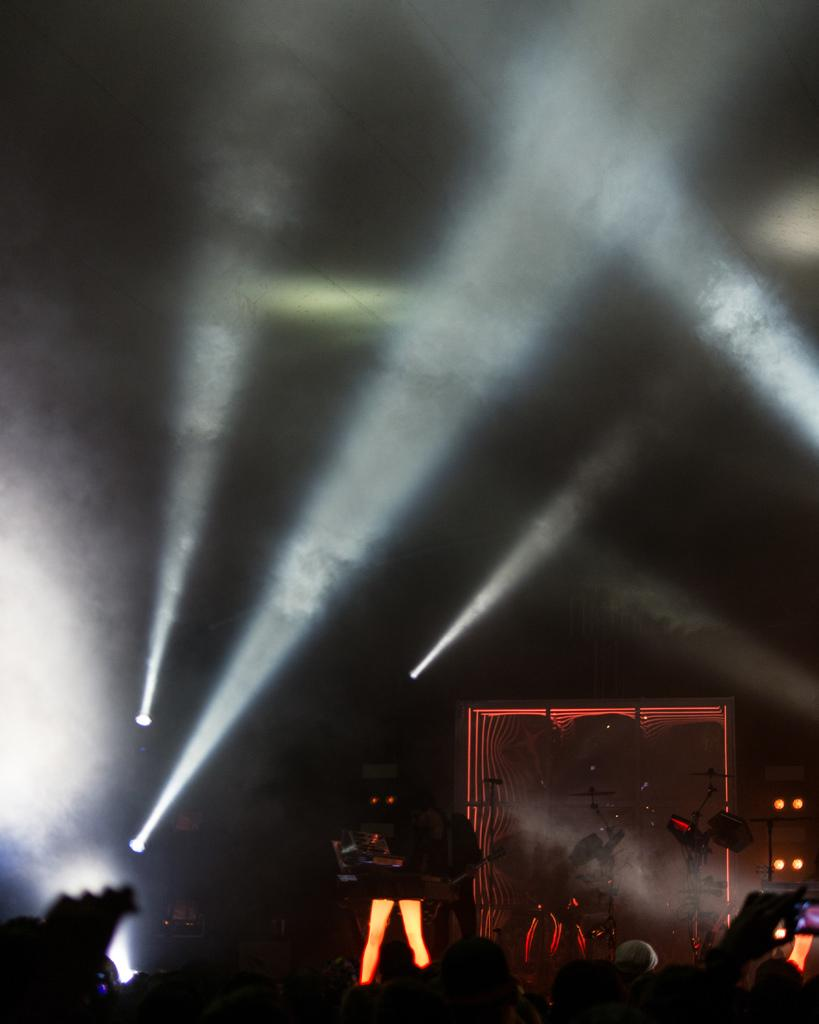What is the overall lighting condition in the image? The image is mostly dark. Can you describe the person in the image? There is a person standing in the image. What else can be seen in the image besides the person? Musical instruments and lights are present in the image. Is there any visible effect caused by the lights? Yes, smoke is present in the image. What year is depicted in the image? The image does not depict a specific year; it is a still image without any time-related context. 